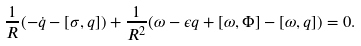<formula> <loc_0><loc_0><loc_500><loc_500>\frac { 1 } { R } ( - \dot { q } - [ \sigma , q ] ) + \frac { 1 } { R ^ { 2 } } ( \omega - \epsilon q + [ \omega , \Phi ] - [ \omega , q ] ) = 0 .</formula> 